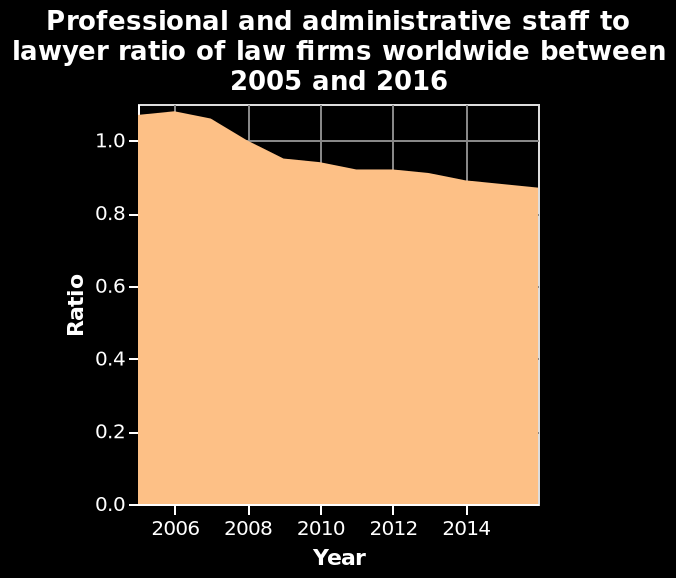<image>
Offer a thorough analysis of the image. As the years pass by the number of administrative staff in comparison to lawyers in law firms proportionally decreases. What is the range of the x-axis?  The x-axis has a range from 2006 to 2014. What does the y-axis represent?  The y-axis represents the ratio of professional and administrative staff to lawyer of law firms. What was the overall change in the trend between 2006 and 2014? The trend decreased slightly over that period. 